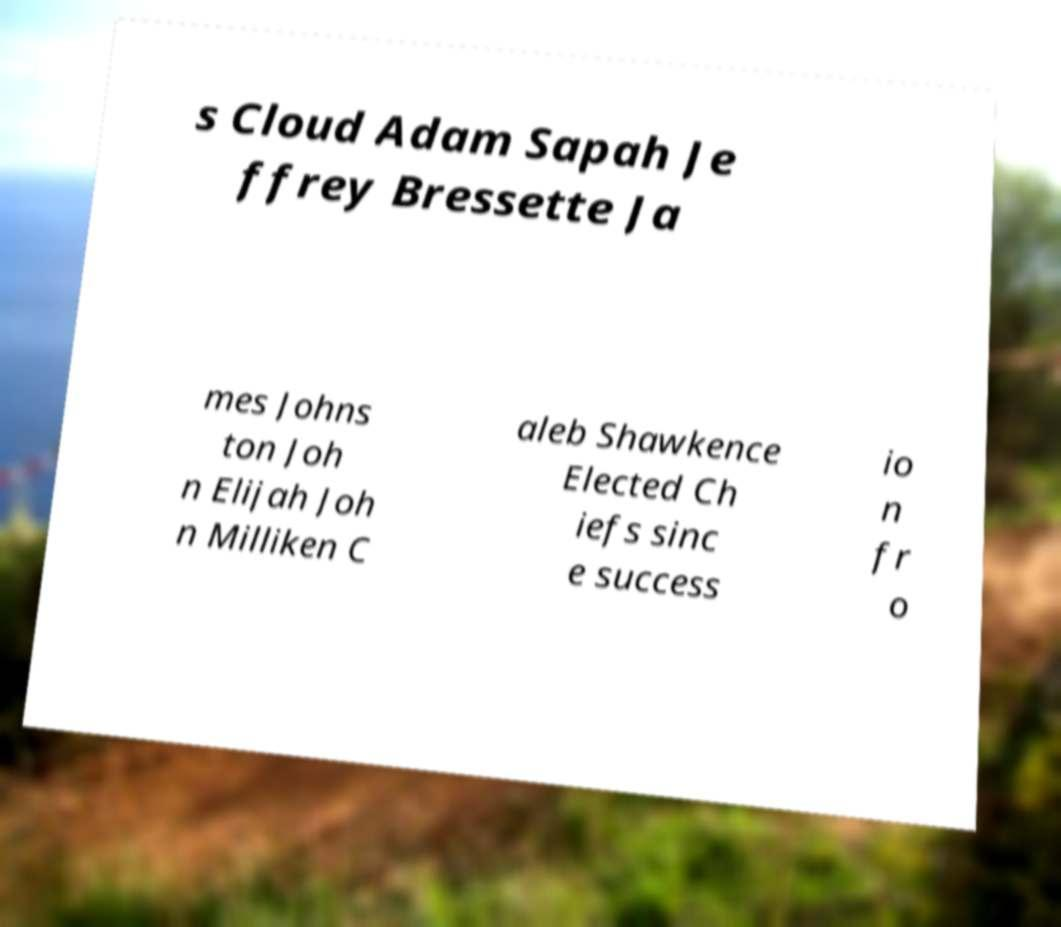Please identify and transcribe the text found in this image. s Cloud Adam Sapah Je ffrey Bressette Ja mes Johns ton Joh n Elijah Joh n Milliken C aleb Shawkence Elected Ch iefs sinc e success io n fr o 